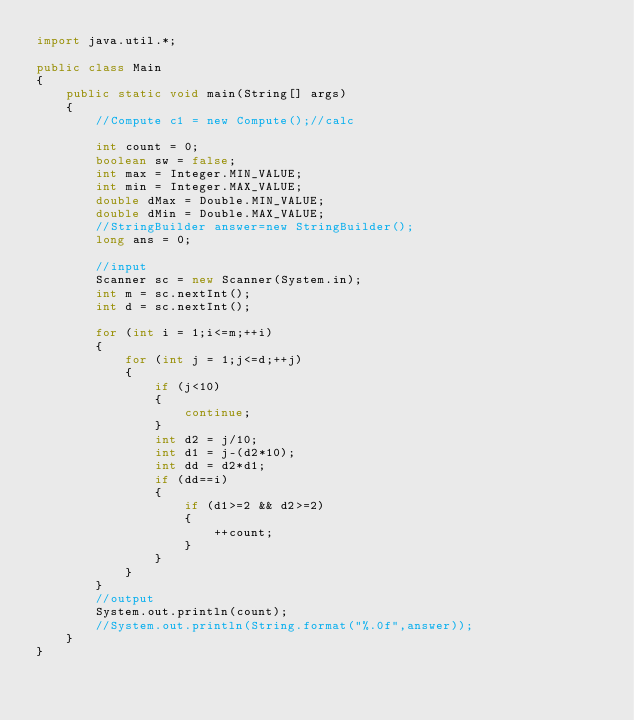<code> <loc_0><loc_0><loc_500><loc_500><_Java_>import java.util.*;

public class Main
{
    public static void main(String[] args)
    {
        //Compute c1 = new Compute();//calc

        int count = 0;
        boolean sw = false;
        int max = Integer.MIN_VALUE;
        int min = Integer.MAX_VALUE;
        double dMax = Double.MIN_VALUE;
        double dMin = Double.MAX_VALUE;
        //StringBuilder answer=new StringBuilder();
        long ans = 0;

        //input
        Scanner sc = new Scanner(System.in);
        int m = sc.nextInt();
        int d = sc.nextInt();

        for (int i = 1;i<=m;++i)
        {
            for (int j = 1;j<=d;++j)
            {
                if (j<10)
                {
                    continue;
                }
                int d2 = j/10;
                int d1 = j-(d2*10);
                int dd = d2*d1;
                if (dd==i)
                {
                    if (d1>=2 && d2>=2)
                    {
                        ++count;
                    }
                }
            }
        }
        //output
        System.out.println(count);
        //System.out.println(String.format("%.0f",answer));
    }
}</code> 